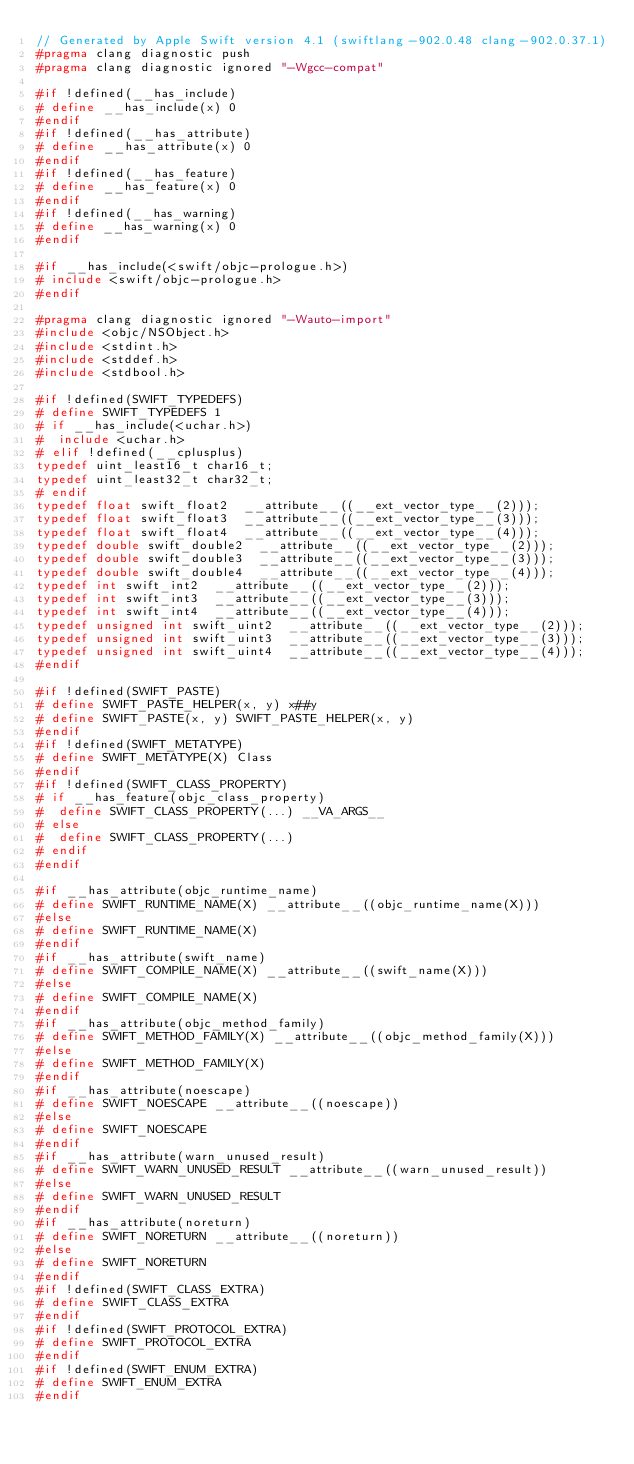<code> <loc_0><loc_0><loc_500><loc_500><_C_>// Generated by Apple Swift version 4.1 (swiftlang-902.0.48 clang-902.0.37.1)
#pragma clang diagnostic push
#pragma clang diagnostic ignored "-Wgcc-compat"

#if !defined(__has_include)
# define __has_include(x) 0
#endif
#if !defined(__has_attribute)
# define __has_attribute(x) 0
#endif
#if !defined(__has_feature)
# define __has_feature(x) 0
#endif
#if !defined(__has_warning)
# define __has_warning(x) 0
#endif

#if __has_include(<swift/objc-prologue.h>)
# include <swift/objc-prologue.h>
#endif

#pragma clang diagnostic ignored "-Wauto-import"
#include <objc/NSObject.h>
#include <stdint.h>
#include <stddef.h>
#include <stdbool.h>

#if !defined(SWIFT_TYPEDEFS)
# define SWIFT_TYPEDEFS 1
# if __has_include(<uchar.h>)
#  include <uchar.h>
# elif !defined(__cplusplus)
typedef uint_least16_t char16_t;
typedef uint_least32_t char32_t;
# endif
typedef float swift_float2  __attribute__((__ext_vector_type__(2)));
typedef float swift_float3  __attribute__((__ext_vector_type__(3)));
typedef float swift_float4  __attribute__((__ext_vector_type__(4)));
typedef double swift_double2  __attribute__((__ext_vector_type__(2)));
typedef double swift_double3  __attribute__((__ext_vector_type__(3)));
typedef double swift_double4  __attribute__((__ext_vector_type__(4)));
typedef int swift_int2  __attribute__((__ext_vector_type__(2)));
typedef int swift_int3  __attribute__((__ext_vector_type__(3)));
typedef int swift_int4  __attribute__((__ext_vector_type__(4)));
typedef unsigned int swift_uint2  __attribute__((__ext_vector_type__(2)));
typedef unsigned int swift_uint3  __attribute__((__ext_vector_type__(3)));
typedef unsigned int swift_uint4  __attribute__((__ext_vector_type__(4)));
#endif

#if !defined(SWIFT_PASTE)
# define SWIFT_PASTE_HELPER(x, y) x##y
# define SWIFT_PASTE(x, y) SWIFT_PASTE_HELPER(x, y)
#endif
#if !defined(SWIFT_METATYPE)
# define SWIFT_METATYPE(X) Class
#endif
#if !defined(SWIFT_CLASS_PROPERTY)
# if __has_feature(objc_class_property)
#  define SWIFT_CLASS_PROPERTY(...) __VA_ARGS__
# else
#  define SWIFT_CLASS_PROPERTY(...)
# endif
#endif

#if __has_attribute(objc_runtime_name)
# define SWIFT_RUNTIME_NAME(X) __attribute__((objc_runtime_name(X)))
#else
# define SWIFT_RUNTIME_NAME(X)
#endif
#if __has_attribute(swift_name)
# define SWIFT_COMPILE_NAME(X) __attribute__((swift_name(X)))
#else
# define SWIFT_COMPILE_NAME(X)
#endif
#if __has_attribute(objc_method_family)
# define SWIFT_METHOD_FAMILY(X) __attribute__((objc_method_family(X)))
#else
# define SWIFT_METHOD_FAMILY(X)
#endif
#if __has_attribute(noescape)
# define SWIFT_NOESCAPE __attribute__((noescape))
#else
# define SWIFT_NOESCAPE
#endif
#if __has_attribute(warn_unused_result)
# define SWIFT_WARN_UNUSED_RESULT __attribute__((warn_unused_result))
#else
# define SWIFT_WARN_UNUSED_RESULT
#endif
#if __has_attribute(noreturn)
# define SWIFT_NORETURN __attribute__((noreturn))
#else
# define SWIFT_NORETURN
#endif
#if !defined(SWIFT_CLASS_EXTRA)
# define SWIFT_CLASS_EXTRA
#endif
#if !defined(SWIFT_PROTOCOL_EXTRA)
# define SWIFT_PROTOCOL_EXTRA
#endif
#if !defined(SWIFT_ENUM_EXTRA)
# define SWIFT_ENUM_EXTRA
#endif</code> 